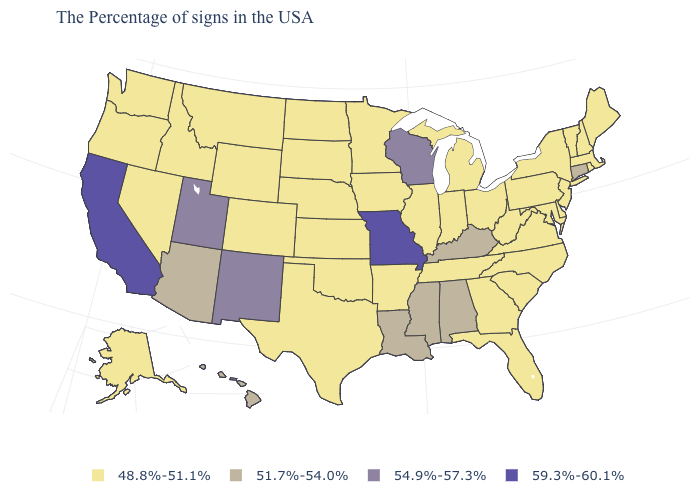Name the states that have a value in the range 51.7%-54.0%?
Keep it brief. Connecticut, Kentucky, Alabama, Mississippi, Louisiana, Arizona, Hawaii. What is the value of South Dakota?
Answer briefly. 48.8%-51.1%. Is the legend a continuous bar?
Quick response, please. No. Among the states that border Louisiana , does Arkansas have the lowest value?
Be succinct. Yes. Does Vermont have the highest value in the USA?
Answer briefly. No. Name the states that have a value in the range 48.8%-51.1%?
Quick response, please. Maine, Massachusetts, Rhode Island, New Hampshire, Vermont, New York, New Jersey, Delaware, Maryland, Pennsylvania, Virginia, North Carolina, South Carolina, West Virginia, Ohio, Florida, Georgia, Michigan, Indiana, Tennessee, Illinois, Arkansas, Minnesota, Iowa, Kansas, Nebraska, Oklahoma, Texas, South Dakota, North Dakota, Wyoming, Colorado, Montana, Idaho, Nevada, Washington, Oregon, Alaska. Among the states that border Arkansas , does Missouri have the lowest value?
Write a very short answer. No. What is the lowest value in states that border Ohio?
Be succinct. 48.8%-51.1%. Does Idaho have a lower value than Alabama?
Short answer required. Yes. What is the value of North Dakota?
Short answer required. 48.8%-51.1%. Name the states that have a value in the range 51.7%-54.0%?
Short answer required. Connecticut, Kentucky, Alabama, Mississippi, Louisiana, Arizona, Hawaii. Does Wisconsin have the lowest value in the USA?
Be succinct. No. What is the highest value in states that border Massachusetts?
Give a very brief answer. 51.7%-54.0%. Does the first symbol in the legend represent the smallest category?
Concise answer only. Yes. 